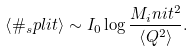Convert formula to latex. <formula><loc_0><loc_0><loc_500><loc_500>\left < \# _ { s } p l i t \right > \sim I _ { 0 } \log \frac { M _ { i } n i t ^ { 2 } } { \left < Q ^ { 2 } \right > } .</formula> 